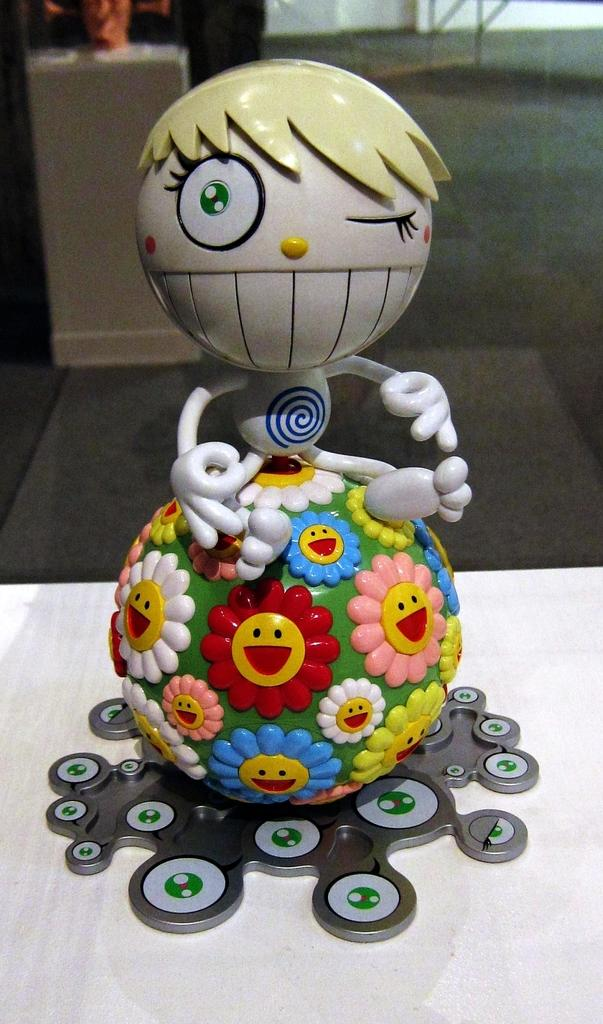What is the main object in the image? There is a toy in the image. What is the color of the surface the toy is on? The toy is on a white surface. Can you describe the background of the image? The background of the image is blurry. Are there any other objects visible in the image besides the toy? Yes, there is an object in the background of the image. What type of knowledge can be gained from the coal in the image? There is no coal present in the image, so no knowledge can be gained from it. 